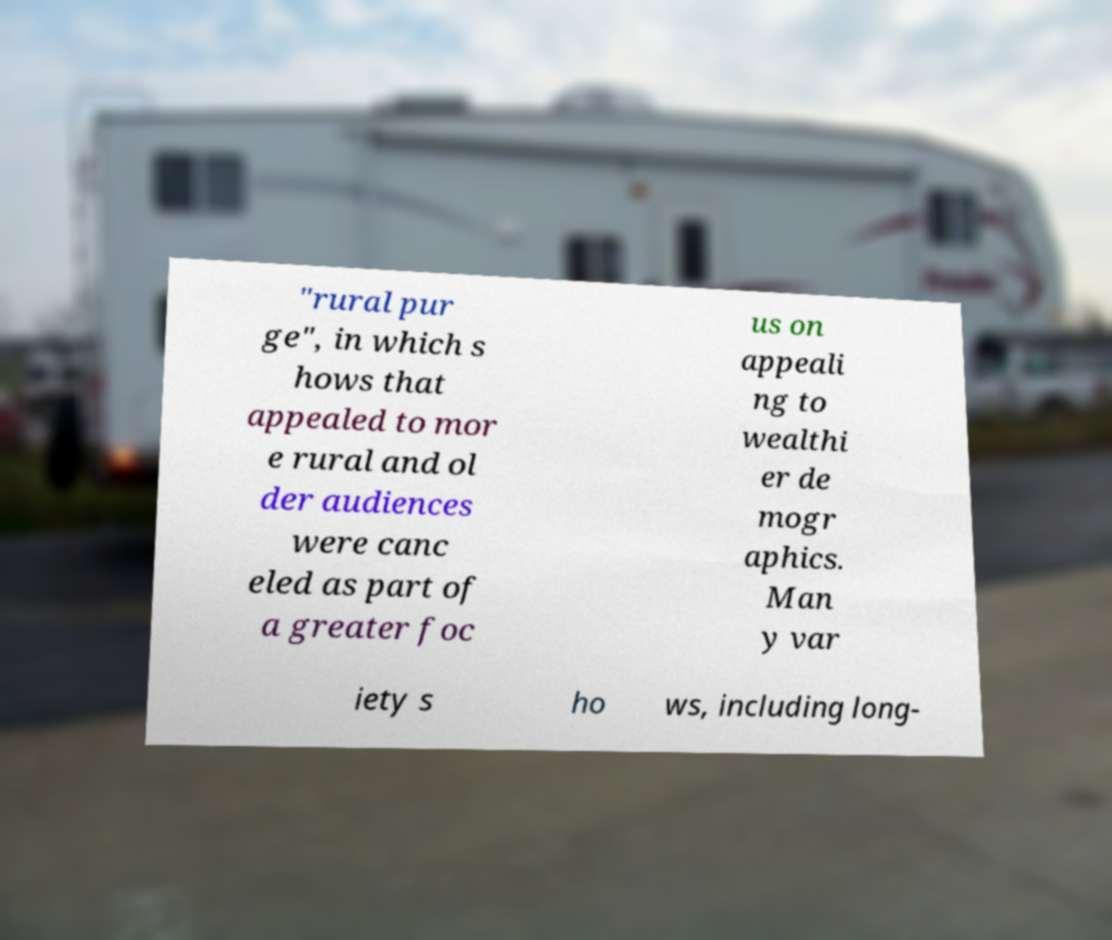Please read and relay the text visible in this image. What does it say? "rural pur ge", in which s hows that appealed to mor e rural and ol der audiences were canc eled as part of a greater foc us on appeali ng to wealthi er de mogr aphics. Man y var iety s ho ws, including long- 